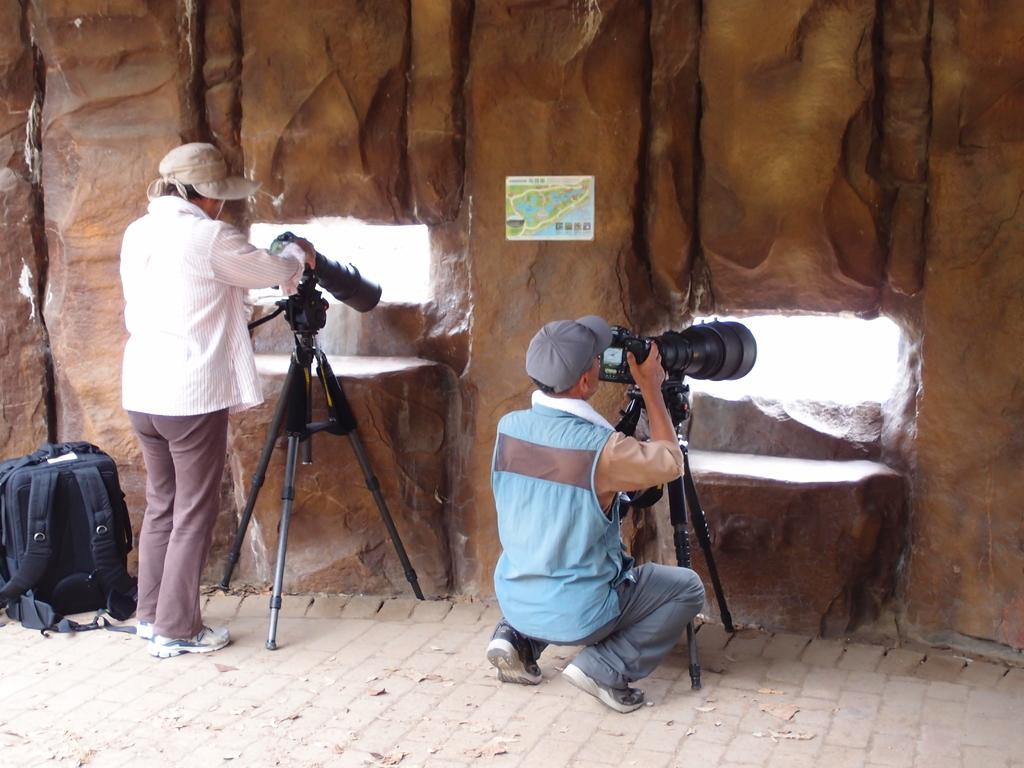Describe this image in one or two sentences. In this image there are two persons wearing white color and blue color dress respectively holding cameras in their hands and at the left side of the image there is a black color bag. 